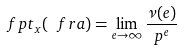<formula> <loc_0><loc_0><loc_500><loc_500>\ f p t _ { x } ( \ f r a ) = \lim _ { e \to \infty } \frac { \nu ( e ) } { p ^ { e } }</formula> 